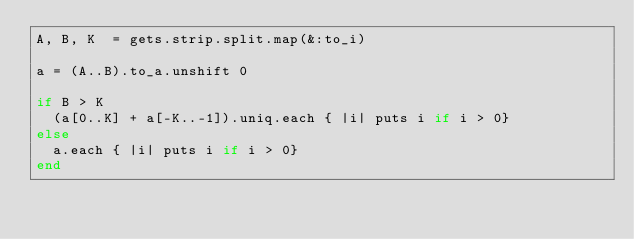Convert code to text. <code><loc_0><loc_0><loc_500><loc_500><_Ruby_>A, B, K  = gets.strip.split.map(&:to_i)

a = (A..B).to_a.unshift 0

if B > K
  (a[0..K] + a[-K..-1]).uniq.each { |i| puts i if i > 0}
else
  a.each { |i| puts i if i > 0}
end
</code> 